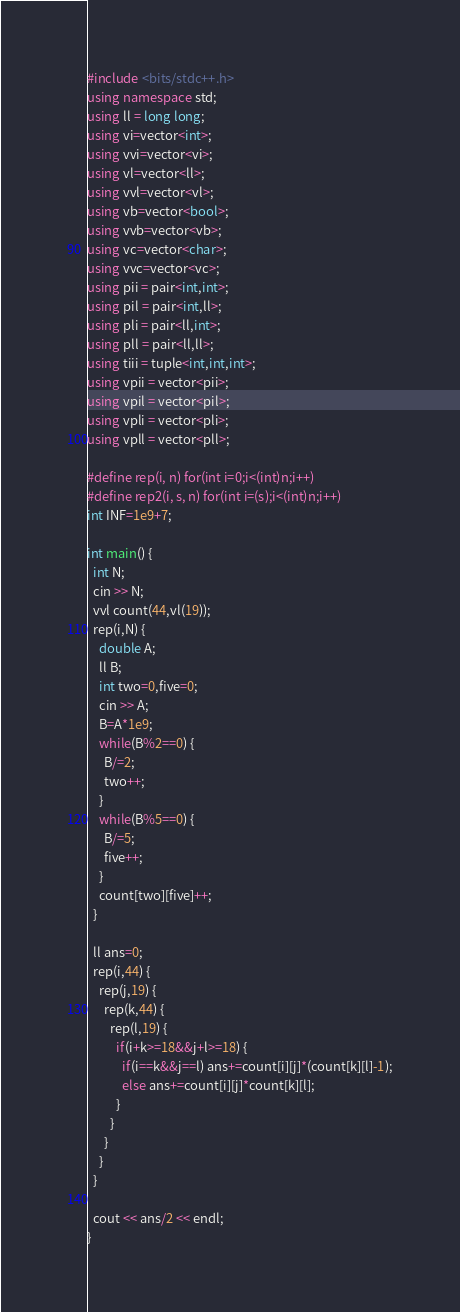Convert code to text. <code><loc_0><loc_0><loc_500><loc_500><_C++_>#include <bits/stdc++.h>
using namespace std;
using ll = long long;
using vi=vector<int>;
using vvi=vector<vi>;
using vl=vector<ll>;
using vvl=vector<vl>;
using vb=vector<bool>;
using vvb=vector<vb>;
using vc=vector<char>;
using vvc=vector<vc>;
using pii = pair<int,int>;
using pil = pair<int,ll>;
using pli = pair<ll,int>;
using pll = pair<ll,ll>;
using tiii = tuple<int,int,int>;
using vpii = vector<pii>;
using vpil = vector<pil>;
using vpli = vector<pli>;
using vpll = vector<pll>;

#define rep(i, n) for(int i=0;i<(int)n;i++)
#define rep2(i, s, n) for(int i=(s);i<(int)n;i++)
int INF=1e9+7;

int main() {
  int N;
  cin >> N;
  vvl count(44,vl(19));
  rep(i,N) {
    double A;
    ll B;
    int two=0,five=0;
    cin >> A;
    B=A*1e9;
    while(B%2==0) {
      B/=2;
      two++;
    }
    while(B%5==0) {
      B/=5;
      five++;
    }
    count[two][five]++;
  }
  
  ll ans=0;
  rep(i,44) {
    rep(j,19) {
      rep(k,44) {
        rep(l,19) {
          if(i+k>=18&&j+l>=18) {
            if(i==k&&j==l) ans+=count[i][j]*(count[k][l]-1);
            else ans+=count[i][j]*count[k][l];
          }
        }
      }
    }
  }
  
  cout << ans/2 << endl;
}</code> 